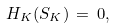<formula> <loc_0><loc_0><loc_500><loc_500>H _ { K } ( S _ { K } ) \, = \, 0 ,</formula> 